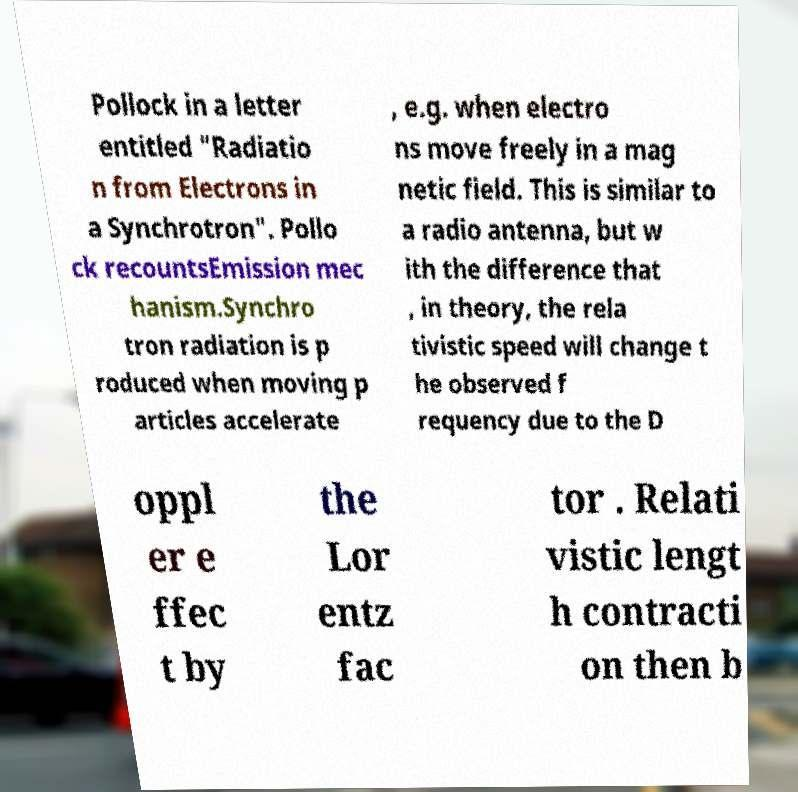Please identify and transcribe the text found in this image. Pollock in a letter entitled "Radiatio n from Electrons in a Synchrotron". Pollo ck recountsEmission mec hanism.Synchro tron radiation is p roduced when moving p articles accelerate , e.g. when electro ns move freely in a mag netic field. This is similar to a radio antenna, but w ith the difference that , in theory, the rela tivistic speed will change t he observed f requency due to the D oppl er e ffec t by the Lor entz fac tor . Relati vistic lengt h contracti on then b 